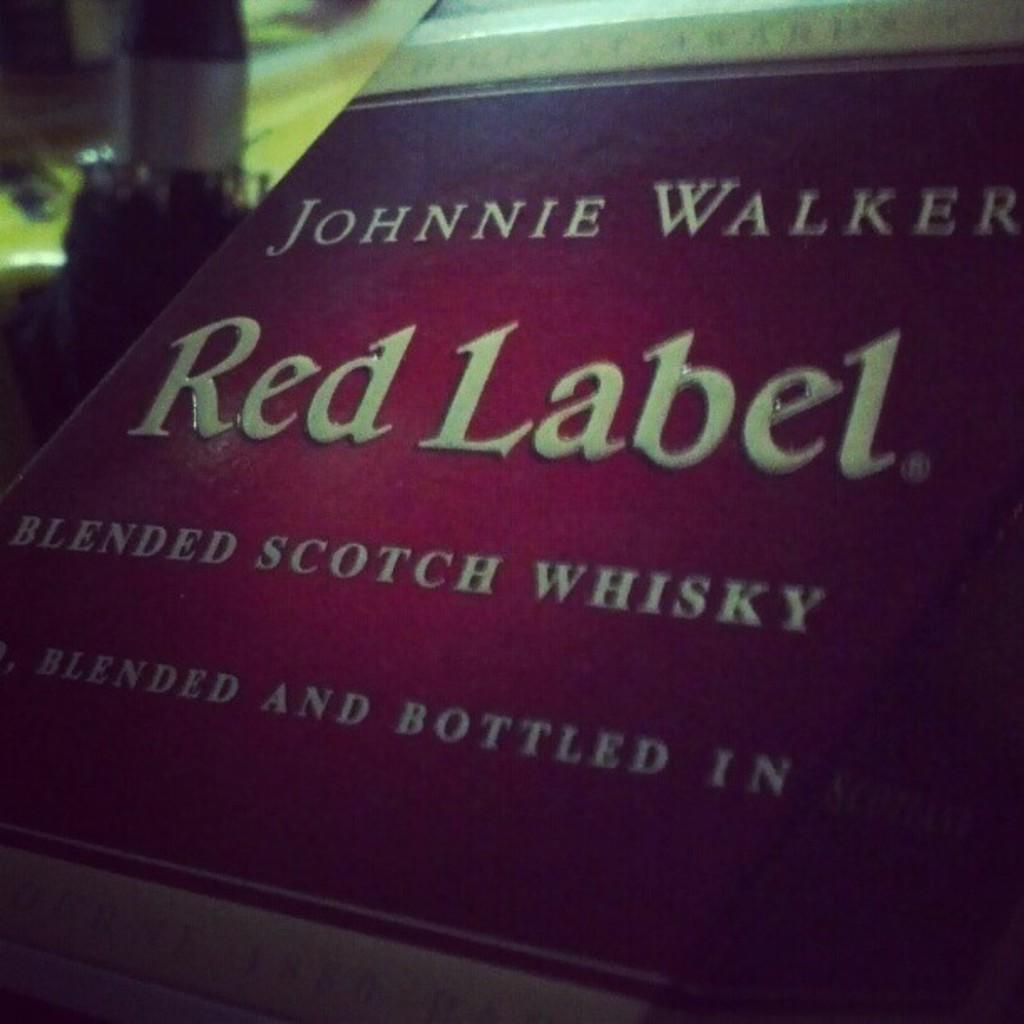<image>
Give a short and clear explanation of the subsequent image. A label reading Johnnie Walker Red Label Blended Scotch whiskey 